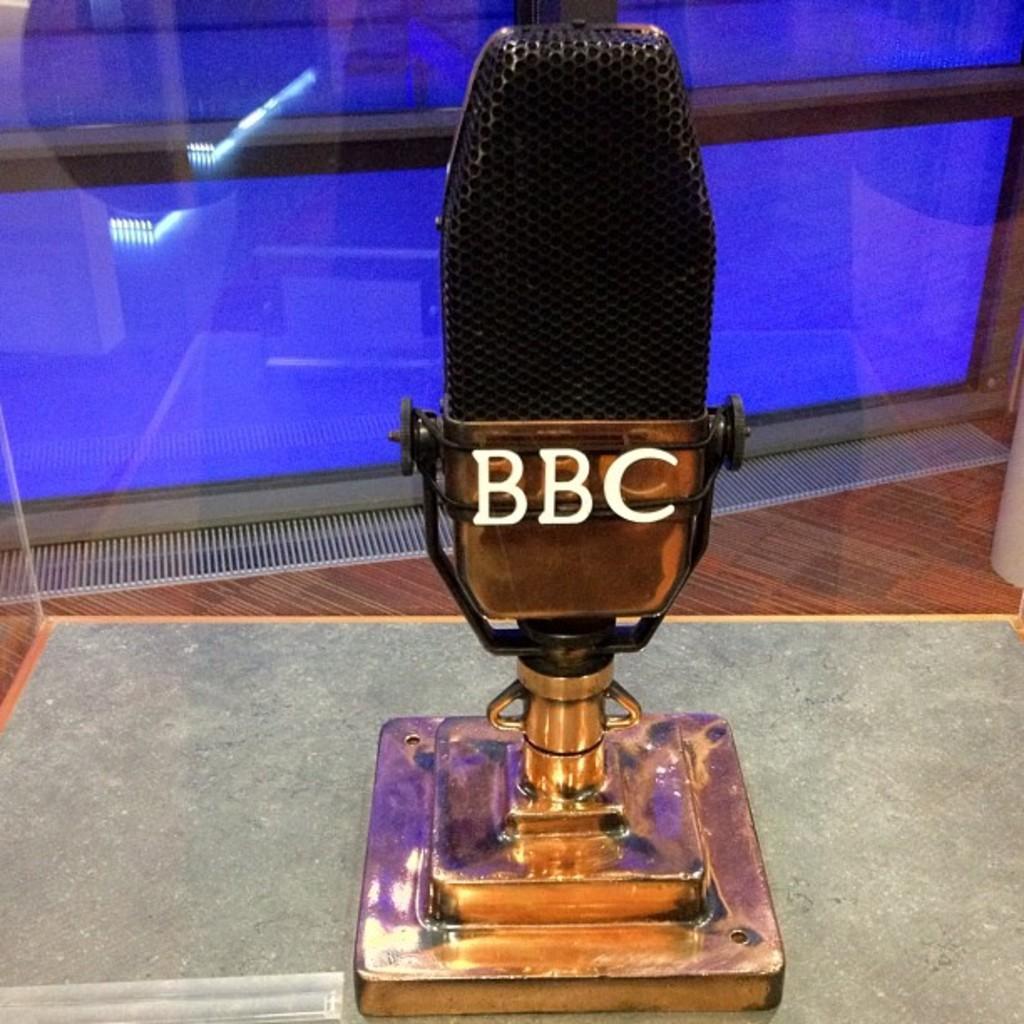In one or two sentences, can you explain what this image depicts? In this image I can see a mile which is placed on a table. On this there is some text. In the background there is a glass. 